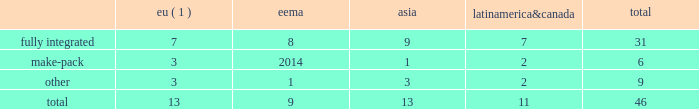2022 the failure of our information systems to function as intended or their penetration by outside parties with the intent to corrupt them or our failure to comply with privacy laws and regulations could result in business disruption , litigation and regulatory action , and loss of revenue , assets or personal or other confidential data .
We use information systems to help manage business processes , collect and interpret business data and communicate internally and externally with employees , suppliers , customers and others .
Some of these information systems are managed by third-party service providers .
We have backup systems and business continuity plans in place , and we take care to protect our systems and data from unauthorized access .
Nevertheless , failure of our systems to function as intended , or penetration of our systems by outside parties intent on extracting or corrupting information or otherwise disrupting business processes , could place us at a competitive disadvantage , result in a loss of revenue , assets or personal or other sensitive data , litigation and regulatory action , cause damage to our reputation and that of our brands and result in significant remediation and other costs .
Failure to protect personal data and respect the rights of data subjects could subject us to substantial fines under regulations such as the eu general data protection regulation .
2022 we may be required to replace third-party contract manufacturers or service providers with our own resources .
In certain instances , we contract with third parties to manufacture some of our products or product parts or to provide other services .
We may be unable to renew these agreements on satisfactory terms for numerous reasons , including government regulations .
Accordingly , our costs may increase significantly if we must replace such third parties with our own resources .
Item 1b .
Unresolved staff comments .
Item 2 .
Properties .
At december 31 , 2017 , we operated and owned 46 manufacturing facilities and maintained contract manufacturing relationships with 25 third-party manufacturers across 23 markets .
In addition , we work with 38 third-party operators in indonesia who manufacture our hand-rolled cigarettes .
Pmi-owned manufacturing facilities eema asia america canada total .
( 1 ) includes facilities that produced heated tobacco units in 2017 .
In 2017 , 23 of our facilities each manufactured over 10 billion cigarettes , of which eight facilities each produced over 30 billion units .
Our largest factories are in karawang and sukorejo ( indonesia ) , izmir ( turkey ) , krakow ( poland ) , st .
Petersburg and krasnodar ( russia ) , batangas and marikina ( philippines ) , berlin ( germany ) , kharkiv ( ukraine ) , and kutna hora ( czech republic ) .
Our smallest factories are mostly in latin america and asia , where due to tariff and other constraints we have established small manufacturing units in individual markets .
We will continue to optimize our manufacturing base , taking into consideration the evolution of trade blocks .
The plants and properties owned or leased and operated by our subsidiaries are maintained in good condition and are believed to be suitable and adequate for our present needs .
We are integrating the production of heated tobacco units into a number of our existing manufacturing facilities and progressing with our plans to build manufacturing capacity for our other rrp platforms. .
What portion of total facilities are fully integrated? 
Computations: (31 / 46)
Answer: 0.67391. 